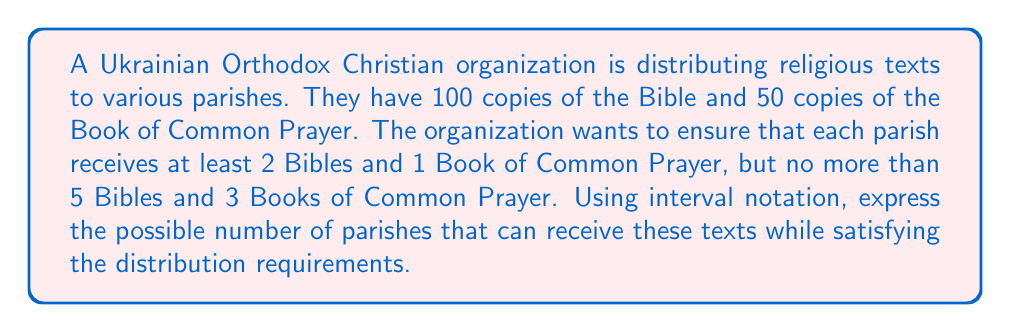Show me your answer to this math problem. Let's approach this step-by-step:

1) First, let's calculate the maximum number of parishes that can be served:
   - For Bibles: $100 \div 2 = 50$ parishes (minimum 2 per parish)
   - For Books of Common Prayer: $50 \div 1 = 50$ parishes (minimum 1 per parish)
   The limiting factor is 50 parishes.

2) Now, let's calculate the minimum number of parishes:
   - For Bibles: $100 \div 5 = 20$ parishes (maximum 5 per parish)
   - For Books of Common Prayer: $50 \div 3 \approx 16.67$ parishes (maximum 3 per parish)
   The limiting factor here is 20 parishes.

3) Therefore, the number of parishes must be at least 20 and at most 50.

4) Since we're dealing with whole numbers of parishes, we need to use the floor function for the lower bound and the ceiling function for the upper bound:

   $$[\lceil 20 \rceil, \lfloor 50 \rfloor]$$

5) Simplifying, as both 20 and 50 are already integers:

   $$[20, 50]$$

This interval notation represents all integer values from 20 to 50, inclusive.
Answer: $[20, 50]$ 